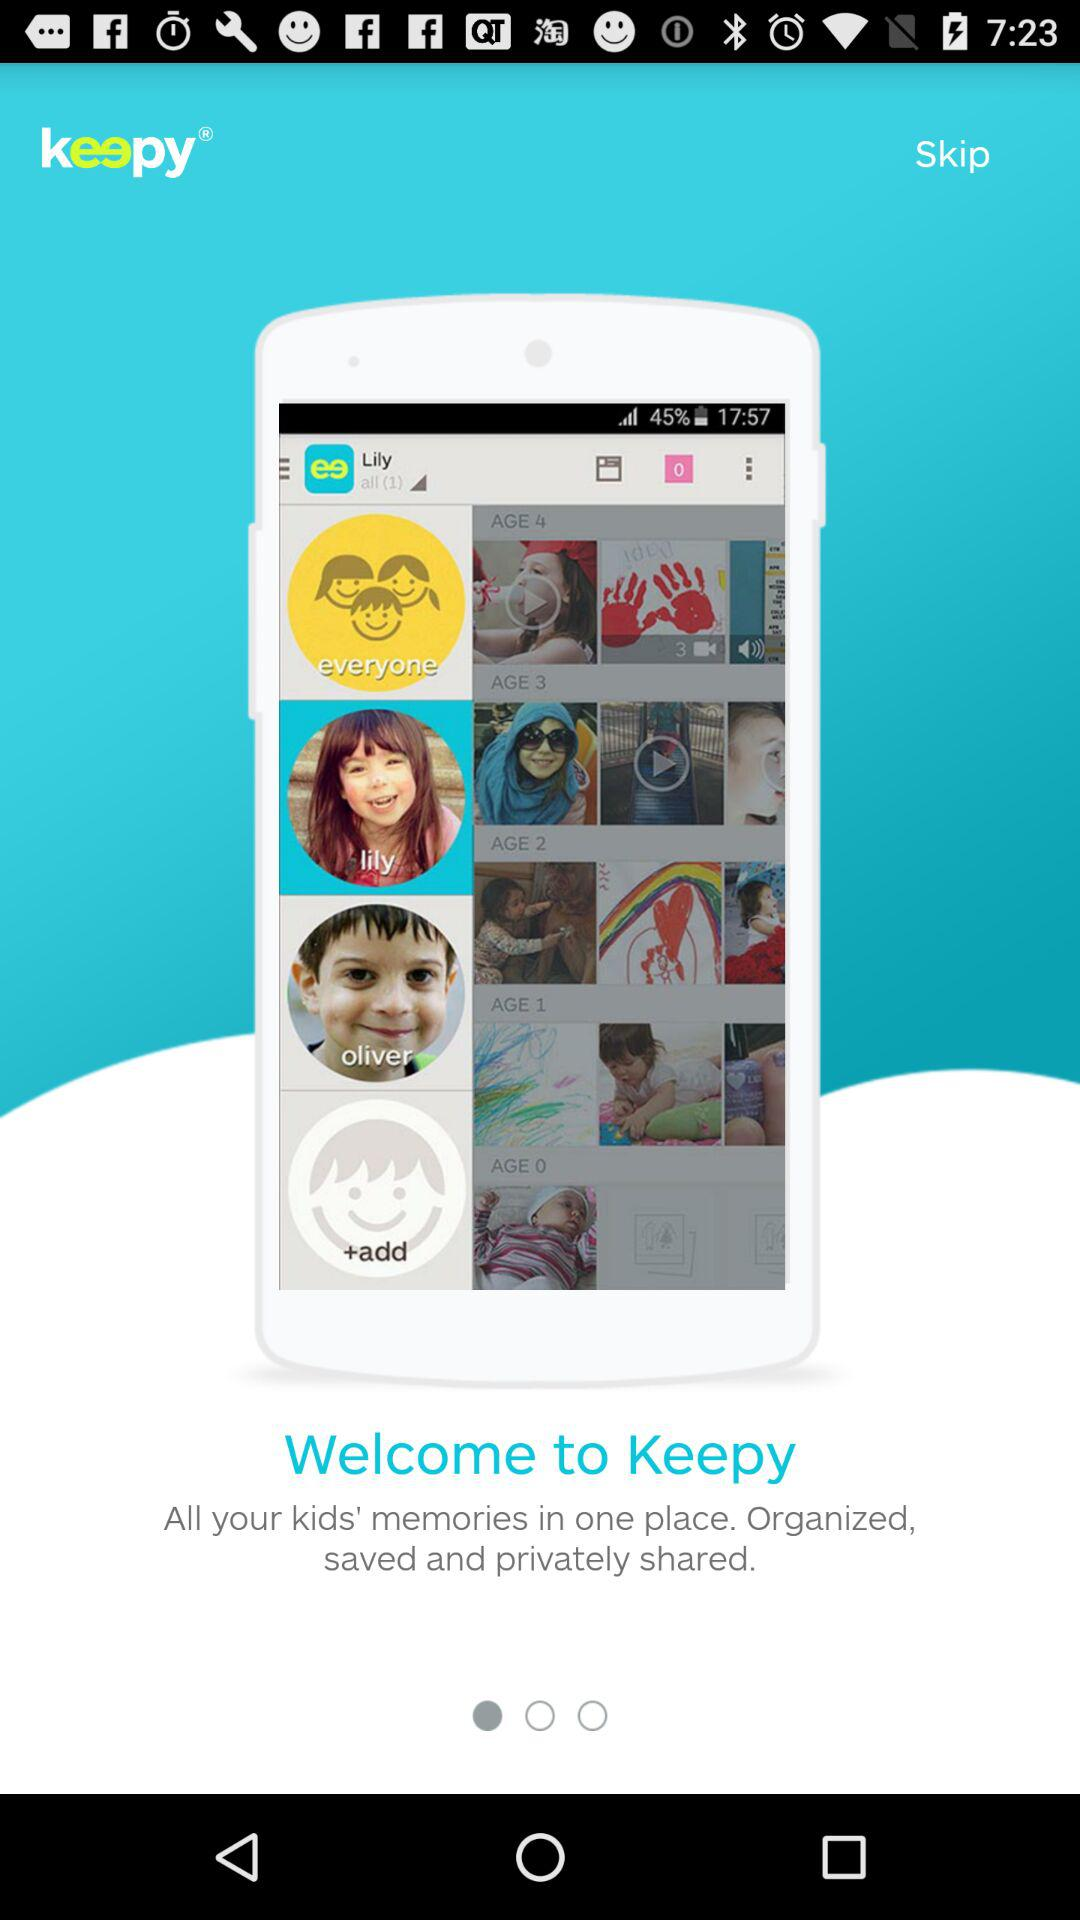What is the name of the application? The name of the application is "Keepy". 